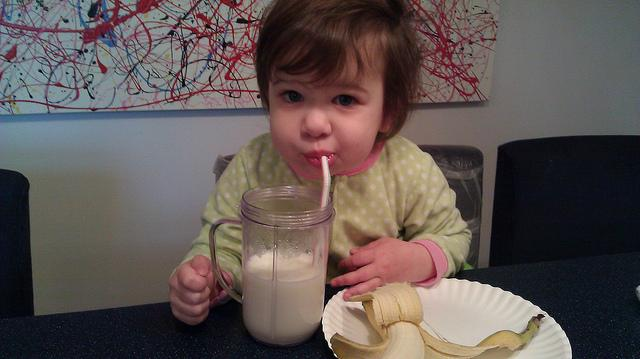What animal is known for eating the item on the plate?

Choices:
A) cheetah
B) badger
C) monkey
D) porcupine monkey 